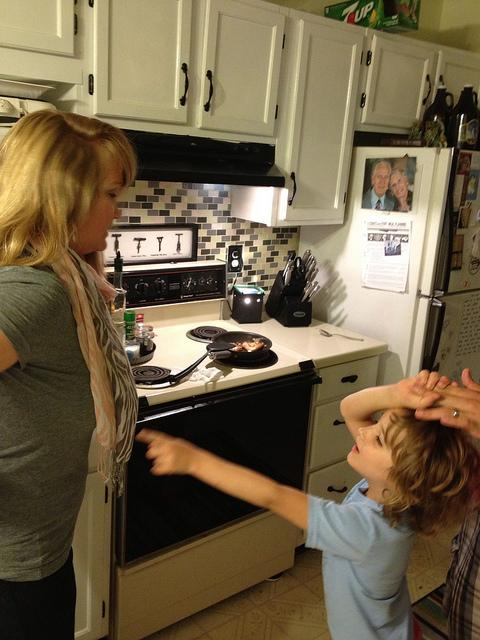What is the original flavor of the beverage? Please explain your reasoning. lemon-lime. There is a box of 7-up which is known to be lemon lime flavored. 